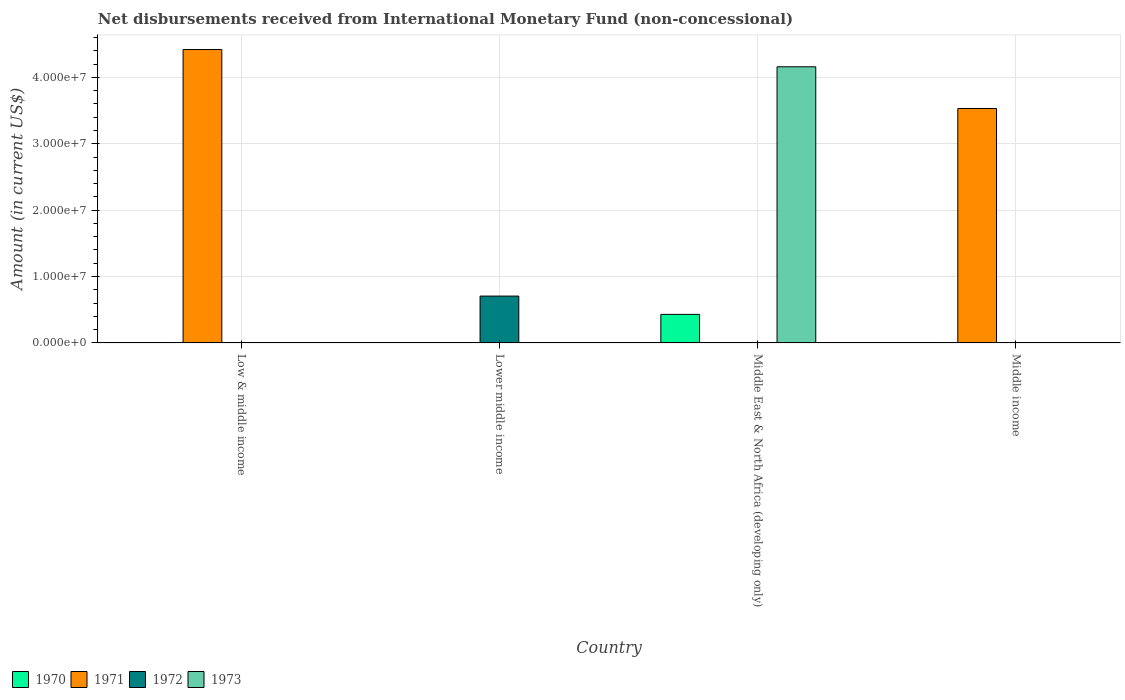How many different coloured bars are there?
Your answer should be compact. 4. Are the number of bars per tick equal to the number of legend labels?
Your response must be concise. No. Are the number of bars on each tick of the X-axis equal?
Your answer should be very brief. No. How many bars are there on the 4th tick from the left?
Offer a terse response. 1. In how many cases, is the number of bars for a given country not equal to the number of legend labels?
Offer a terse response. 4. Across all countries, what is the maximum amount of disbursements received from International Monetary Fund in 1971?
Offer a terse response. 4.42e+07. What is the total amount of disbursements received from International Monetary Fund in 1973 in the graph?
Offer a terse response. 4.16e+07. What is the difference between the amount of disbursements received from International Monetary Fund in 1972 in Low & middle income and the amount of disbursements received from International Monetary Fund in 1970 in Middle income?
Your response must be concise. 0. What is the average amount of disbursements received from International Monetary Fund in 1970 per country?
Ensure brevity in your answer.  1.08e+06. What is the difference between the highest and the lowest amount of disbursements received from International Monetary Fund in 1970?
Make the answer very short. 4.30e+06. In how many countries, is the amount of disbursements received from International Monetary Fund in 1970 greater than the average amount of disbursements received from International Monetary Fund in 1970 taken over all countries?
Your response must be concise. 1. Are all the bars in the graph horizontal?
Make the answer very short. No. How many countries are there in the graph?
Keep it short and to the point. 4. What is the difference between two consecutive major ticks on the Y-axis?
Give a very brief answer. 1.00e+07. How many legend labels are there?
Provide a short and direct response. 4. What is the title of the graph?
Ensure brevity in your answer.  Net disbursements received from International Monetary Fund (non-concessional). What is the label or title of the X-axis?
Your answer should be compact. Country. What is the label or title of the Y-axis?
Give a very brief answer. Amount (in current US$). What is the Amount (in current US$) in 1971 in Low & middle income?
Make the answer very short. 4.42e+07. What is the Amount (in current US$) of 1973 in Low & middle income?
Provide a short and direct response. 0. What is the Amount (in current US$) in 1971 in Lower middle income?
Offer a terse response. 0. What is the Amount (in current US$) of 1972 in Lower middle income?
Provide a short and direct response. 7.06e+06. What is the Amount (in current US$) of 1970 in Middle East & North Africa (developing only)?
Provide a short and direct response. 4.30e+06. What is the Amount (in current US$) in 1972 in Middle East & North Africa (developing only)?
Provide a short and direct response. 0. What is the Amount (in current US$) in 1973 in Middle East & North Africa (developing only)?
Make the answer very short. 4.16e+07. What is the Amount (in current US$) of 1970 in Middle income?
Offer a very short reply. 0. What is the Amount (in current US$) in 1971 in Middle income?
Offer a terse response. 3.53e+07. What is the Amount (in current US$) in 1972 in Middle income?
Provide a short and direct response. 0. What is the Amount (in current US$) of 1973 in Middle income?
Provide a short and direct response. 0. Across all countries, what is the maximum Amount (in current US$) in 1970?
Your answer should be very brief. 4.30e+06. Across all countries, what is the maximum Amount (in current US$) of 1971?
Your response must be concise. 4.42e+07. Across all countries, what is the maximum Amount (in current US$) of 1972?
Your answer should be compact. 7.06e+06. Across all countries, what is the maximum Amount (in current US$) in 1973?
Your response must be concise. 4.16e+07. What is the total Amount (in current US$) of 1970 in the graph?
Provide a succinct answer. 4.30e+06. What is the total Amount (in current US$) of 1971 in the graph?
Ensure brevity in your answer.  7.95e+07. What is the total Amount (in current US$) of 1972 in the graph?
Provide a succinct answer. 7.06e+06. What is the total Amount (in current US$) in 1973 in the graph?
Give a very brief answer. 4.16e+07. What is the difference between the Amount (in current US$) of 1971 in Low & middle income and that in Middle income?
Offer a very short reply. 8.88e+06. What is the difference between the Amount (in current US$) of 1971 in Low & middle income and the Amount (in current US$) of 1972 in Lower middle income?
Your response must be concise. 3.71e+07. What is the difference between the Amount (in current US$) in 1971 in Low & middle income and the Amount (in current US$) in 1973 in Middle East & North Africa (developing only)?
Make the answer very short. 2.60e+06. What is the difference between the Amount (in current US$) in 1972 in Lower middle income and the Amount (in current US$) in 1973 in Middle East & North Africa (developing only)?
Keep it short and to the point. -3.45e+07. What is the difference between the Amount (in current US$) in 1970 in Middle East & North Africa (developing only) and the Amount (in current US$) in 1971 in Middle income?
Make the answer very short. -3.10e+07. What is the average Amount (in current US$) of 1970 per country?
Your answer should be very brief. 1.08e+06. What is the average Amount (in current US$) in 1971 per country?
Make the answer very short. 1.99e+07. What is the average Amount (in current US$) in 1972 per country?
Offer a very short reply. 1.76e+06. What is the average Amount (in current US$) in 1973 per country?
Provide a short and direct response. 1.04e+07. What is the difference between the Amount (in current US$) of 1970 and Amount (in current US$) of 1973 in Middle East & North Africa (developing only)?
Your answer should be compact. -3.73e+07. What is the ratio of the Amount (in current US$) in 1971 in Low & middle income to that in Middle income?
Offer a terse response. 1.25. What is the difference between the highest and the lowest Amount (in current US$) in 1970?
Your response must be concise. 4.30e+06. What is the difference between the highest and the lowest Amount (in current US$) of 1971?
Ensure brevity in your answer.  4.42e+07. What is the difference between the highest and the lowest Amount (in current US$) of 1972?
Offer a very short reply. 7.06e+06. What is the difference between the highest and the lowest Amount (in current US$) of 1973?
Provide a short and direct response. 4.16e+07. 